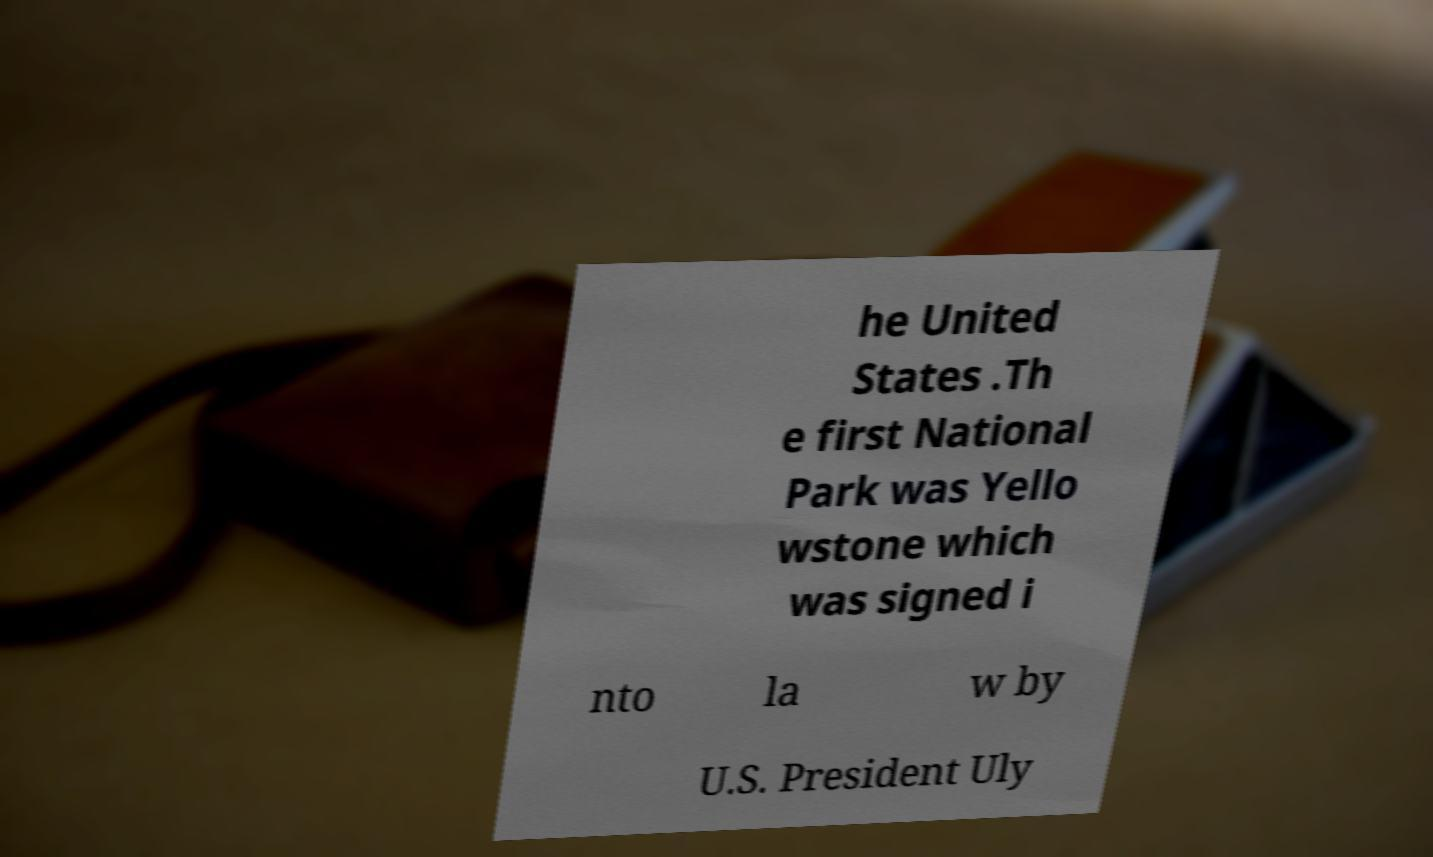Can you read and provide the text displayed in the image?This photo seems to have some interesting text. Can you extract and type it out for me? he United States .Th e first National Park was Yello wstone which was signed i nto la w by U.S. President Uly 